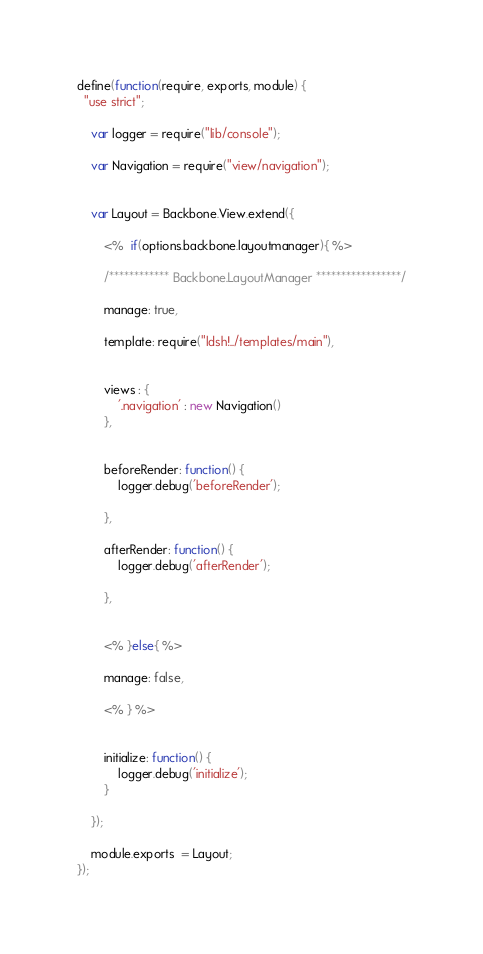Convert code to text. <code><loc_0><loc_0><loc_500><loc_500><_JavaScript_>
define(function(require, exports, module) {
  "use strict";

  	var logger = require("lib/console");

  	var Navigation = require("view/navigation");


	var Layout = Backbone.View.extend({

		<%  if(options.backbone.layoutmanager){ %>

		/************ Backbone.LayoutManager *****************/

		manage: true,

		template: require("ldsh!../templates/main"),


		views : {
			'.navigation' : new Navigation()
		},


		beforeRender: function() {
			logger.debug('beforeRender');

		},

		afterRender: function() {
			logger.debug('afterRender');

		},


		<% }else{ %>

		manage: false,

		<% } %>


		initialize: function() {
			logger.debug('initialize');
		}

	});

	module.exports  = Layout;
});</code> 